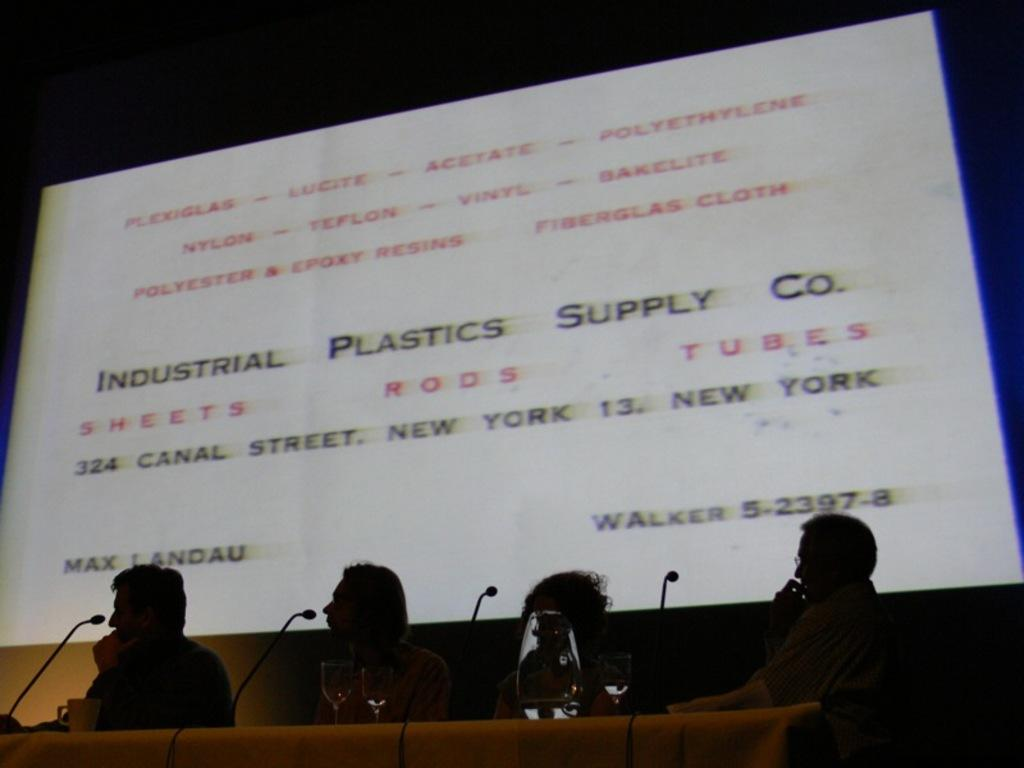How many people are present in the image? There are four people in the image. What objects are in front of the people? There are microphones, glasses, a cup, and other objects in front of the people. What can be seen in the background of the image? There is a screen visible in the background of the image. What type of vegetable is being used as a leg for one of the people in the image? There are no vegetables or legs being used as a leg for any of the people in the image. 